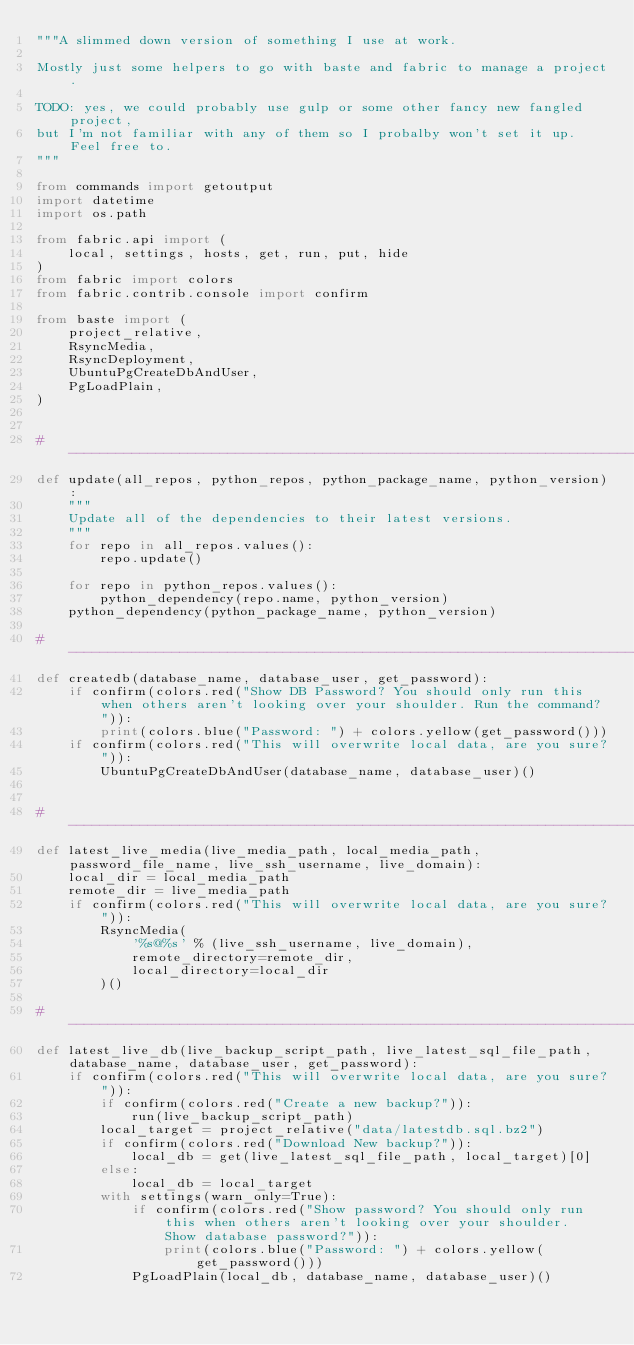Convert code to text. <code><loc_0><loc_0><loc_500><loc_500><_Python_>"""A slimmed down version of something I use at work.

Mostly just some helpers to go with baste and fabric to manage a project.

TODO: yes, we could probably use gulp or some other fancy new fangled project,
but I'm not familiar with any of them so I probalby won't set it up. Feel free to.
"""

from commands import getoutput
import datetime
import os.path

from fabric.api import (
    local, settings, hosts, get, run, put, hide
)
from fabric import colors
from fabric.contrib.console import confirm

from baste import (
    project_relative,
    RsyncMedia,
    RsyncDeployment,
    UbuntuPgCreateDbAndUser,
    PgLoadPlain,
)


#-------------------------------------------------------------------------------
def update(all_repos, python_repos, python_package_name, python_version):
    """
    Update all of the dependencies to their latest versions.
    """
    for repo in all_repos.values():
        repo.update()

    for repo in python_repos.values():
        python_dependency(repo.name, python_version)
    python_dependency(python_package_name, python_version)

#-------------------------------------------------------------------------------
def createdb(database_name, database_user, get_password):
    if confirm(colors.red("Show DB Password? You should only run this when others aren't looking over your shoulder. Run the command?")):
        print(colors.blue("Password: ") + colors.yellow(get_password()))
    if confirm(colors.red("This will overwrite local data, are you sure?")):
        UbuntuPgCreateDbAndUser(database_name, database_user)()


#-------------------------------------------------------------------------------
def latest_live_media(live_media_path, local_media_path, password_file_name, live_ssh_username, live_domain):
    local_dir = local_media_path
    remote_dir = live_media_path
    if confirm(colors.red("This will overwrite local data, are you sure?")):
        RsyncMedia(
            '%s@%s' % (live_ssh_username, live_domain),
            remote_directory=remote_dir,
            local_directory=local_dir
        )()

#-------------------------------------------------------------------------------
def latest_live_db(live_backup_script_path, live_latest_sql_file_path, database_name, database_user, get_password):
    if confirm(colors.red("This will overwrite local data, are you sure?")):
        if confirm(colors.red("Create a new backup?")):
            run(live_backup_script_path)
        local_target = project_relative("data/latestdb.sql.bz2")
        if confirm(colors.red("Download New backup?")):
            local_db = get(live_latest_sql_file_path, local_target)[0]
        else:
            local_db = local_target
        with settings(warn_only=True):
            if confirm(colors.red("Show password? You should only run this when others aren't looking over your shoulder. Show database password?")):
                print(colors.blue("Password: ") + colors.yellow(get_password()))
            PgLoadPlain(local_db, database_name, database_user)()

</code> 